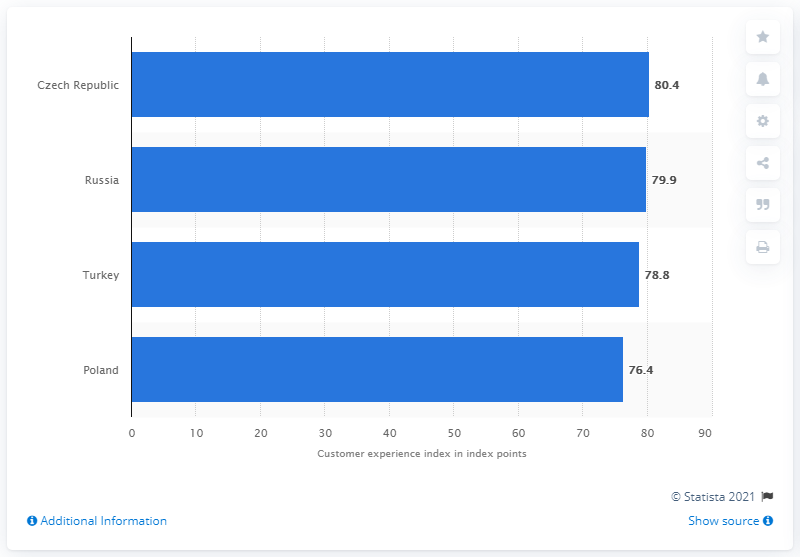Point out several critical features in this image. To find the average of all blue bars, we calculated the value of 78.875 and rounded it down to 78.87. As of 2016, the level of the customer experience index for the Czech Republic was 80.4. The country named Czech Republic displays a blue bar with the value of 80.4. 